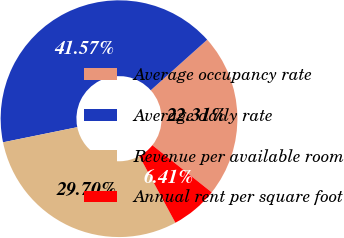Convert chart to OTSL. <chart><loc_0><loc_0><loc_500><loc_500><pie_chart><fcel>Average occupancy rate<fcel>Average daily rate<fcel>Revenue per available room<fcel>Annual rent per square foot<nl><fcel>22.31%<fcel>41.57%<fcel>29.7%<fcel>6.41%<nl></chart> 